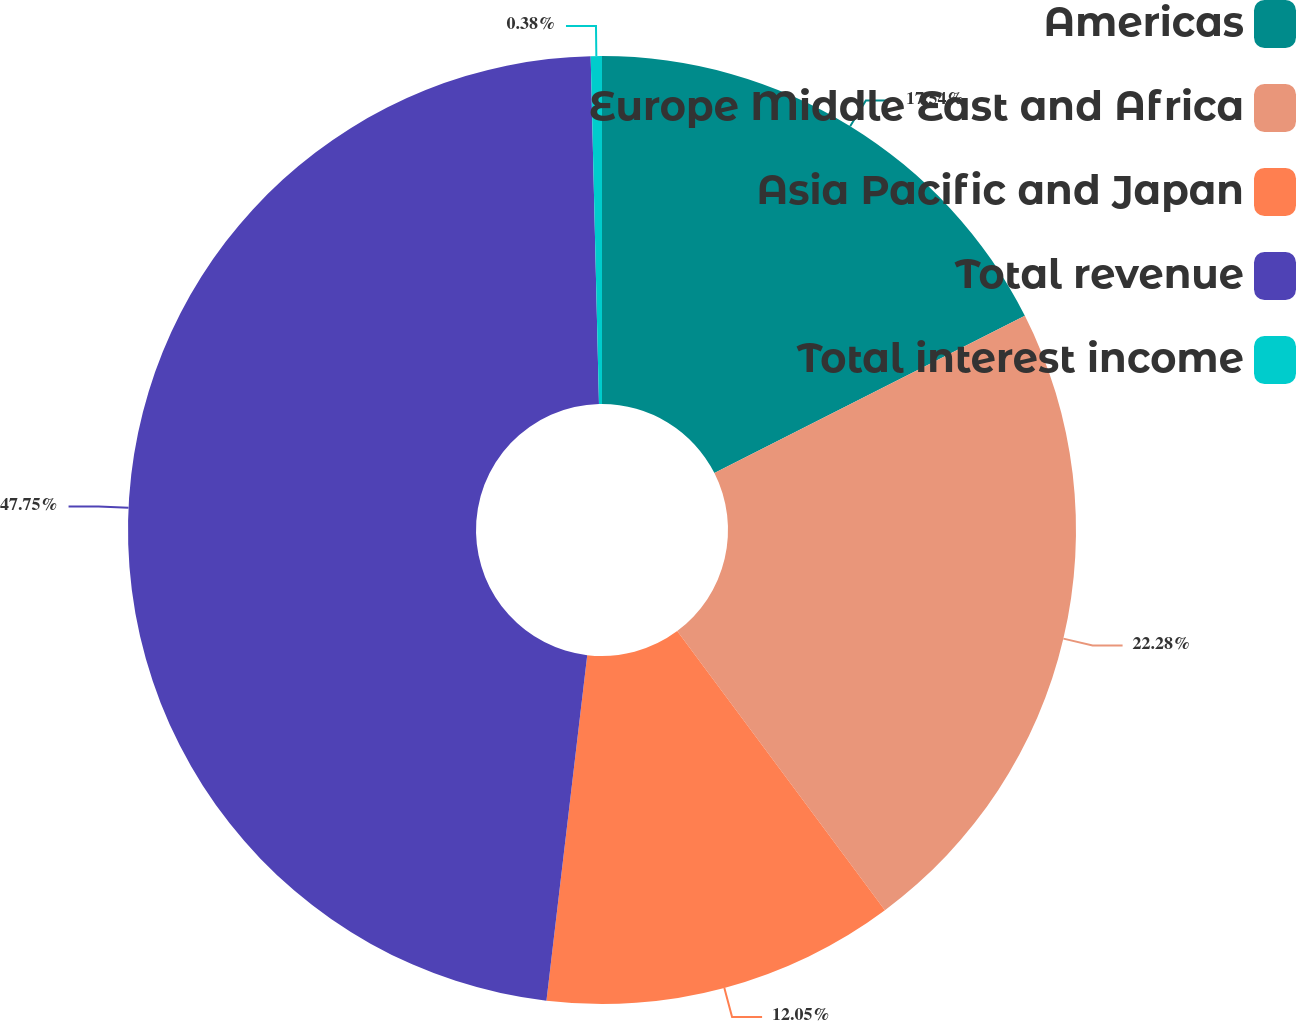<chart> <loc_0><loc_0><loc_500><loc_500><pie_chart><fcel>Americas<fcel>Europe Middle East and Africa<fcel>Asia Pacific and Japan<fcel>Total revenue<fcel>Total interest income<nl><fcel>17.54%<fcel>22.28%<fcel>12.05%<fcel>47.75%<fcel>0.38%<nl></chart> 